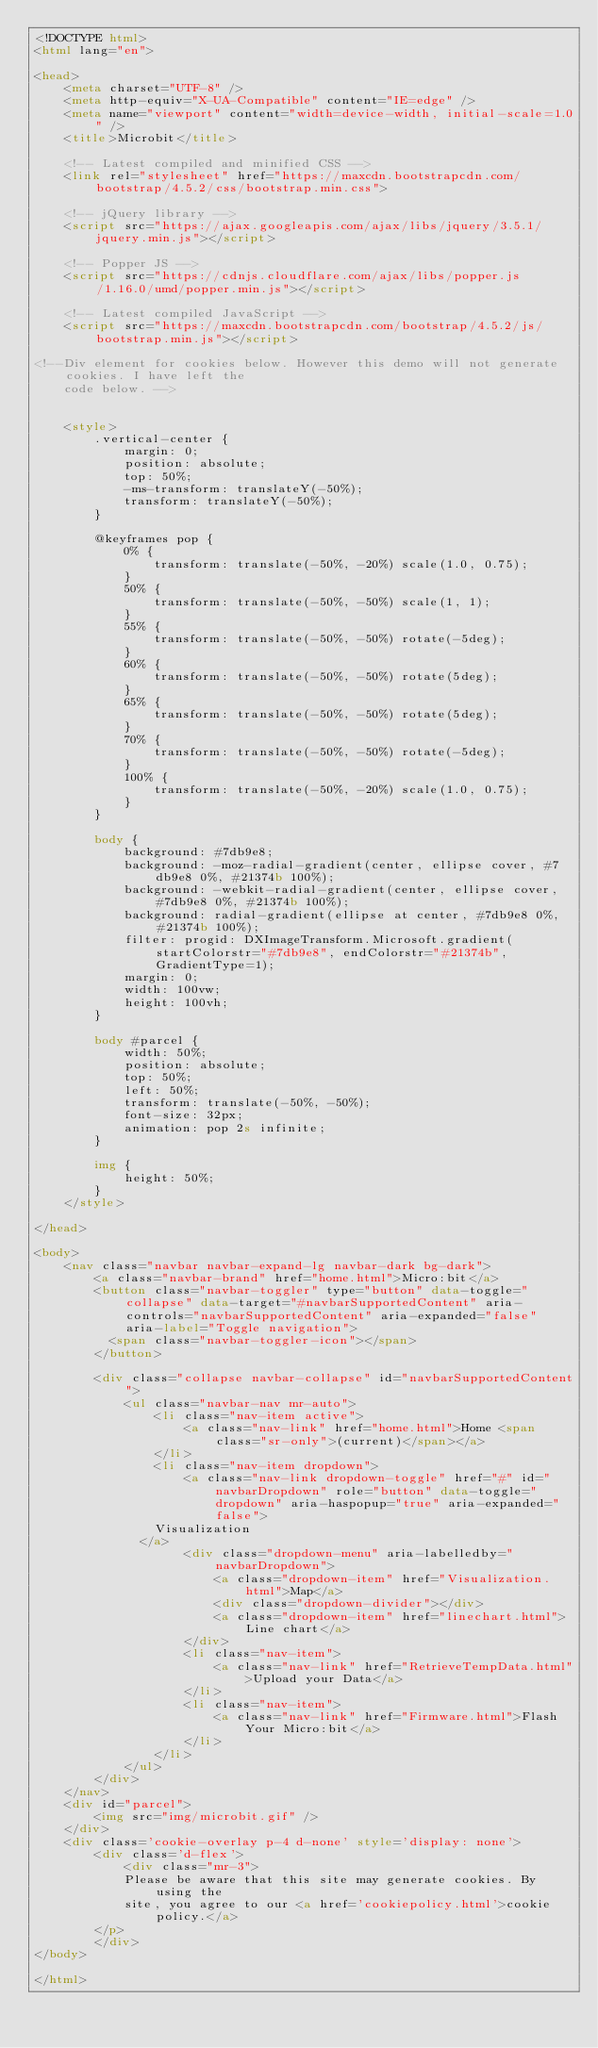<code> <loc_0><loc_0><loc_500><loc_500><_HTML_><!DOCTYPE html>
<html lang="en">

<head>
    <meta charset="UTF-8" />
    <meta http-equiv="X-UA-Compatible" content="IE=edge" />
    <meta name="viewport" content="width=device-width, initial-scale=1.0" />
    <title>Microbit</title>

    <!-- Latest compiled and minified CSS -->
    <link rel="stylesheet" href="https://maxcdn.bootstrapcdn.com/bootstrap/4.5.2/css/bootstrap.min.css">

    <!-- jQuery library -->
    <script src="https://ajax.googleapis.com/ajax/libs/jquery/3.5.1/jquery.min.js"></script>

    <!-- Popper JS -->
    <script src="https://cdnjs.cloudflare.com/ajax/libs/popper.js/1.16.0/umd/popper.min.js"></script>

    <!-- Latest compiled JavaScript -->
    <script src="https://maxcdn.bootstrapcdn.com/bootstrap/4.5.2/js/bootstrap.min.js"></script>

<!--Div element for cookies below. However this demo will not generate cookies. I have left the 
    code below. -->


    <style>
        .vertical-center {
            margin: 0;
            position: absolute;
            top: 50%;
            -ms-transform: translateY(-50%);
            transform: translateY(-50%);
        }
        
        @keyframes pop {
            0% {
                transform: translate(-50%, -20%) scale(1.0, 0.75);
            }
            50% {
                transform: translate(-50%, -50%) scale(1, 1);
            }
            55% {
                transform: translate(-50%, -50%) rotate(-5deg);
            }
            60% {
                transform: translate(-50%, -50%) rotate(5deg);
            }
            65% {
                transform: translate(-50%, -50%) rotate(5deg);
            }
            70% {
                transform: translate(-50%, -50%) rotate(-5deg);
            }
            100% {
                transform: translate(-50%, -20%) scale(1.0, 0.75);
            }
        }
        
        body {
            background: #7db9e8;
            background: -moz-radial-gradient(center, ellipse cover, #7db9e8 0%, #21374b 100%);
            background: -webkit-radial-gradient(center, ellipse cover, #7db9e8 0%, #21374b 100%);
            background: radial-gradient(ellipse at center, #7db9e8 0%, #21374b 100%);
            filter: progid: DXImageTransform.Microsoft.gradient( startColorstr="#7db9e8", endColorstr="#21374b", GradientType=1);
            margin: 0;
            width: 100vw;
            height: 100vh;
        }
        
        body #parcel {
            width: 50%;
            position: absolute;
            top: 50%;
            left: 50%;
            transform: translate(-50%, -50%);
            font-size: 32px;
            animation: pop 2s infinite;
        }
        
        img {
            height: 50%;
        }
    </style>

</head>

<body>
    <nav class="navbar navbar-expand-lg navbar-dark bg-dark">
        <a class="navbar-brand" href="home.html">Micro:bit</a>
        <button class="navbar-toggler" type="button" data-toggle="collapse" data-target="#navbarSupportedContent" aria-controls="navbarSupportedContent" aria-expanded="false" aria-label="Toggle navigation">
          <span class="navbar-toggler-icon"></span>
        </button>

        <div class="collapse navbar-collapse" id="navbarSupportedContent">
            <ul class="navbar-nav mr-auto">
                <li class="nav-item active">
                    <a class="nav-link" href="home.html">Home <span class="sr-only">(current)</span></a>
                </li>
                <li class="nav-item dropdown">
                    <a class="nav-link dropdown-toggle" href="#" id="navbarDropdown" role="button" data-toggle="dropdown" aria-haspopup="true" aria-expanded="false">
                Visualization
              </a>
                    <div class="dropdown-menu" aria-labelledby="navbarDropdown">
                        <a class="dropdown-item" href="Visualization.html">Map</a>
                        <div class="dropdown-divider"></div>
                        <a class="dropdown-item" href="linechart.html">Line chart</a>
                    </div>
                    <li class="nav-item">
                        <a class="nav-link" href="RetrieveTempData.html">Upload your Data</a>
                    </li>
                    <li class="nav-item">
                        <a class="nav-link" href="Firmware.html">Flash Your Micro:bit</a>
                    </li>
                </li>
            </ul>
        </div>
    </nav>
    <div id="parcel">
        <img src="img/microbit.gif" />
    </div>
    <div class='cookie-overlay p-4 d-none' style='display: none'>
        <div class='d-flex'>
            <div class="mr-3">
            Please be aware that this site may generate cookies. By using the
            site, you agree to our <a href='cookiepolicy.html'>cookie policy.</a>
        </p>
        </div>
</body>

</html></code> 